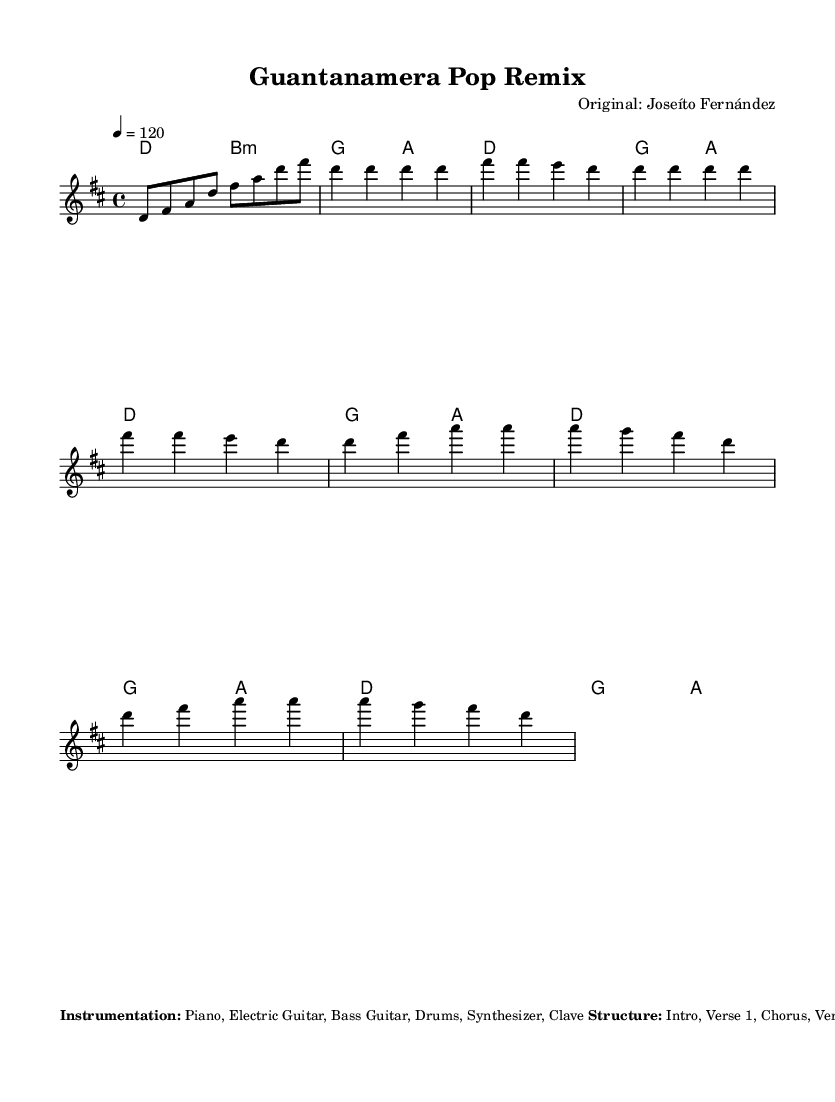What is the key signature of this music? The key signature is indicated at the beginning of the score, and it shows two sharps. For the key of D major, which has the notes F# and C#, the signature represents this.
Answer: D major What is the time signature of this music? The time signature is located right after the key signature. It shows a '4/4', indicating that there are four beats per measure and a quarter note receives one beat.
Answer: 4/4 What is the tempo of the piece? The tempo marking is given at the start of the score, stated as '4 = 120', which indicates that a quarter note gets 120 beats per minute.
Answer: 120 How many sections are there in the structure? The structure indicates different parts such as Intro, Verse, Chorus, Bridge, and Outro. In total, there are 7 specified sections listed under the additional notes.
Answer: 7 What rhythm pattern is used for the drums? The sheet music describes the rhythm as a "Four-on-the-floor kick drum pattern," which provides a steady beat, and adds syncopation for emphasis on beats two and four.
Answer: Four-on-the-floor What instruments are incorporated in the arrangement? The instrumentation is listed under the additional notes where it specifies Piano, Electric Guitar, Bass Guitar, Drums, Synthesizer, and Clave as the instruments used.
Answer: Piano, Electric Guitar, Bass Guitar, Drums, Synthesizer, Clave What is a notable feature of the vocal effects in the chorus? The additional notes mention the incorporation of modern pop vocal effects during the chorus, specifically indicating the use of autotune and delay, which are common in contemporary pop music production.
Answer: Autotune and delay 